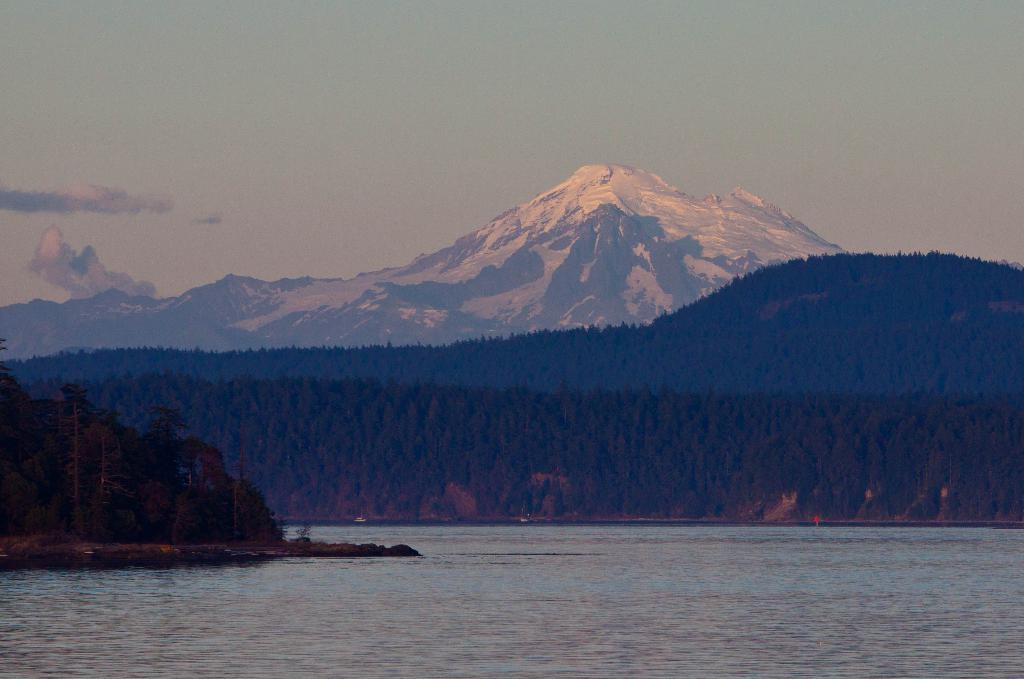What is the primary element visible in the image? There is water in the image. What can be seen in the distance in the image? There are trees, mountains, and the sky visible in the background of the image. What type of potato is being prepared by the fireman in the image? There is no potato or fireman present in the image. 